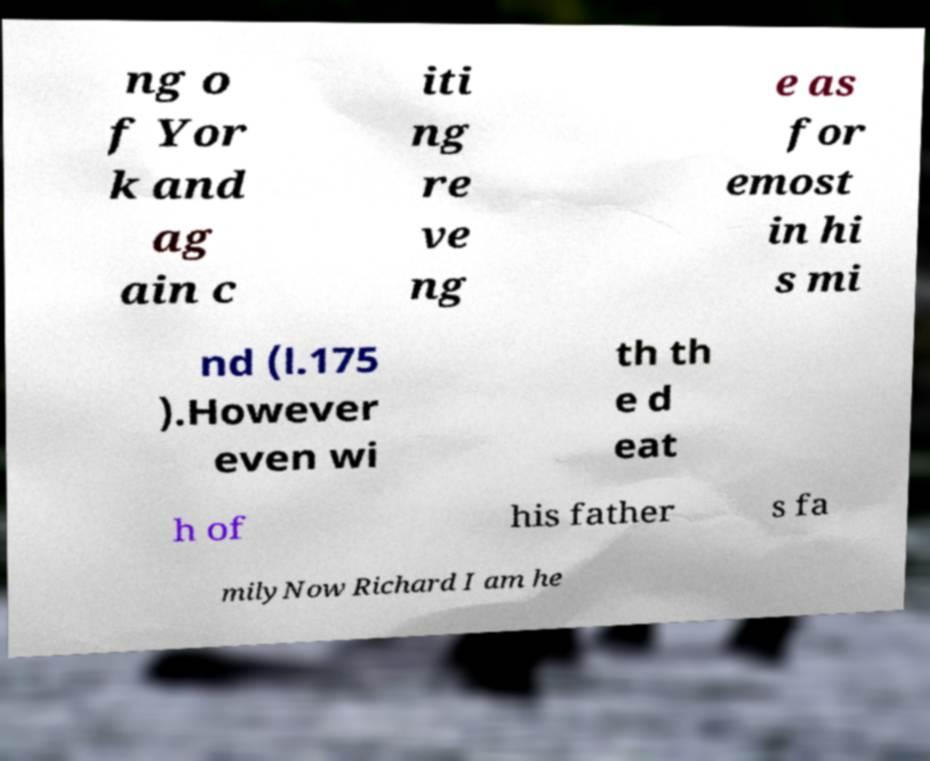Could you extract and type out the text from this image? ng o f Yor k and ag ain c iti ng re ve ng e as for emost in hi s mi nd (l.175 ).However even wi th th e d eat h of his father s fa milyNow Richard I am he 